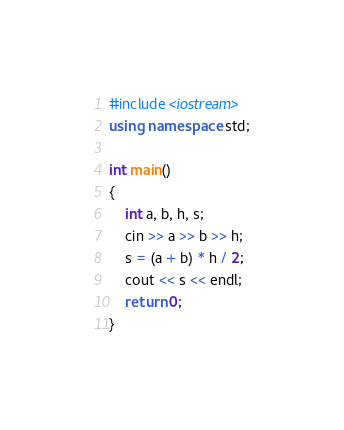Convert code to text. <code><loc_0><loc_0><loc_500><loc_500><_C++_>#include <iostream>
using namespace std;

int main()
{
    int a, b, h, s;
    cin >> a >> b >> h;
    s = (a + b) * h / 2;
    cout << s << endl;
    return 0;
}
</code> 